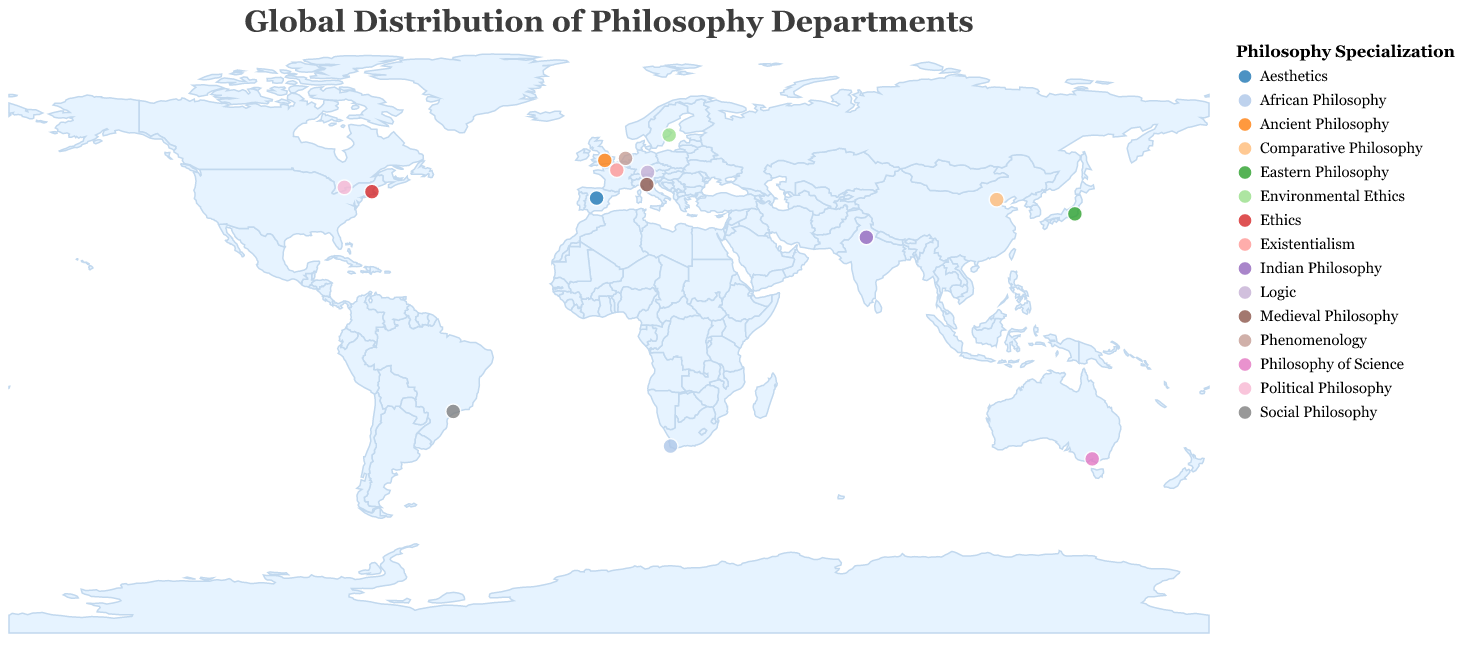How many philosophy departments are represented on the map? Count the data points represented by the circles on the map. Each circle corresponds to a philosophy department.
Answer: 15 Which country has the most philosophy departments listed? Look at the tooltip information by hovering over the circles to identify the country associated with each department. Count the occurrences for each country and compare.
Answer: USA Which university specializes in Medieval Philosophy? Hover over the circles to view the tooltip details. Locate the specialization "Medieval Philosophy" in the tooltip and identify the corresponding university.
Answer: University of Bologna What is the specialization of the philosophy department at the University of Tokyo? Hover over the circle located at the coordinates corresponding to the University of Tokyo. Read the tooltip to identify the specialization.
Answer: Eastern Philosophy Are there more philosophy departments specializing in Ethics or Existentialism? Count the number of instances where the tooltip shows the specialization as "Ethics" and "Existentialism," then compare the counts.
Answer: Ethics What is the westernmost university on the map? Look at the longitudes of all the data points (longitude being the x-axis). Identify the most negative (west) longitude.
Answer: Harvard University Which specializations are found in European universities? Hover over circles located in Europe and note the specializations listed in the tooltip for universities located in the European region.
Answer: Ancient Philosophy, Logic, Existentialism, Phenomenology, Aesthetics, Medieval Philosophy, Environmental Ethics Are there any philosophy departments in the Southern Hemisphere? If so, what specializations do they have? Look at the latitudes of all the data points to identify which ones are negative (Southern Hemisphere). Note the specializations for these points.
Answer: Yes, Philosophy of Science (University of Melbourne), Social Philosophy (University of São Paulo), African Philosophy (University of Cape Town) Which specialization is unique to only one university? Hover over each circle to read the tooltip details. Note which specializations appear only once across all data points.
Answer: Eastern Philosophy, Indian Philosophy, Comparative Philosophy, African Philosophy 